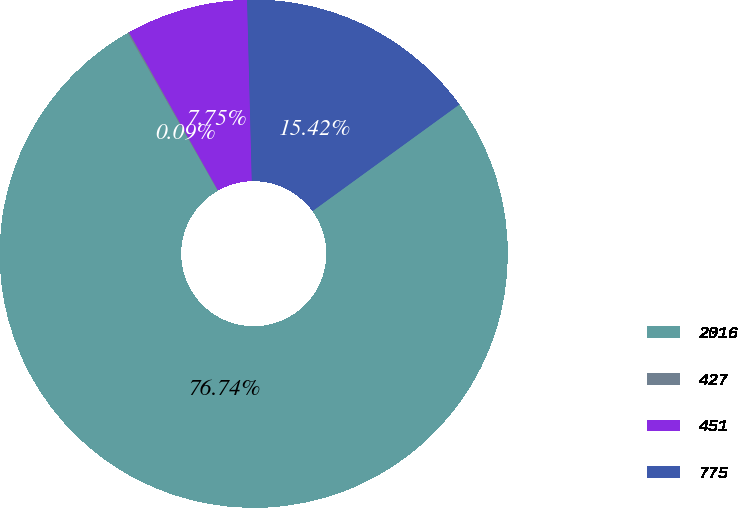<chart> <loc_0><loc_0><loc_500><loc_500><pie_chart><fcel>2016<fcel>427<fcel>451<fcel>775<nl><fcel>76.74%<fcel>0.09%<fcel>7.75%<fcel>15.42%<nl></chart> 